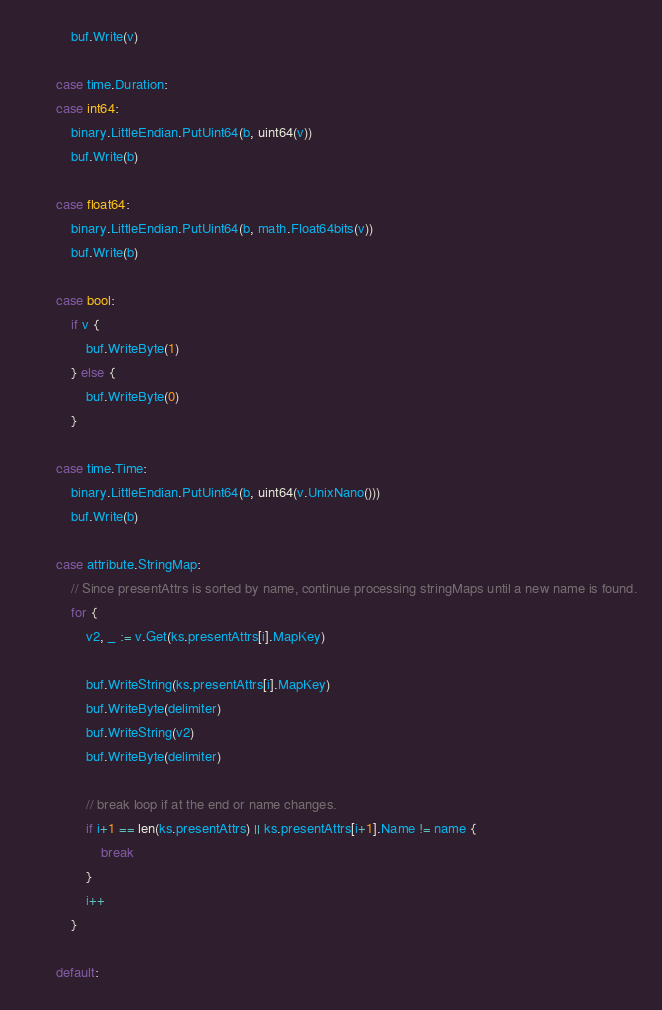Convert code to text. <code><loc_0><loc_0><loc_500><loc_500><_Go_>			buf.Write(v)

		case time.Duration:
		case int64:
			binary.LittleEndian.PutUint64(b, uint64(v))
			buf.Write(b)

		case float64:
			binary.LittleEndian.PutUint64(b, math.Float64bits(v))
			buf.Write(b)

		case bool:
			if v {
				buf.WriteByte(1)
			} else {
				buf.WriteByte(0)
			}

		case time.Time:
			binary.LittleEndian.PutUint64(b, uint64(v.UnixNano()))
			buf.Write(b)

		case attribute.StringMap:
			// Since presentAttrs is sorted by name, continue processing stringMaps until a new name is found.
			for {
				v2, _ := v.Get(ks.presentAttrs[i].MapKey)

				buf.WriteString(ks.presentAttrs[i].MapKey)
				buf.WriteByte(delimiter)
				buf.WriteString(v2)
				buf.WriteByte(delimiter)

				// break loop if at the end or name changes.
				if i+1 == len(ks.presentAttrs) || ks.presentAttrs[i+1].Name != name {
					break
				}
				i++
			}

		default:</code> 